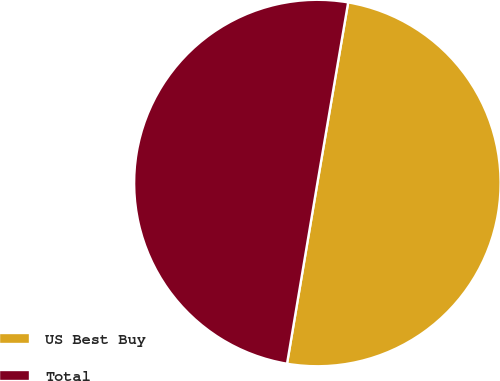Convert chart to OTSL. <chart><loc_0><loc_0><loc_500><loc_500><pie_chart><fcel>US Best Buy<fcel>Total<nl><fcel>49.96%<fcel>50.04%<nl></chart> 